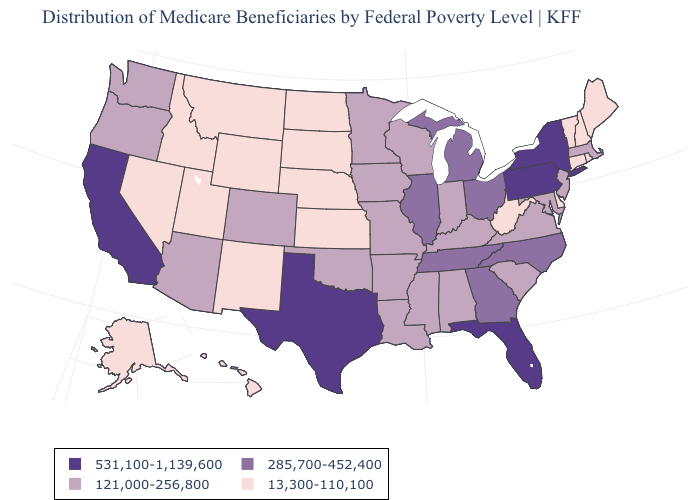Does California have the highest value in the USA?
Answer briefly. Yes. Does Delaware have the lowest value in the South?
Be succinct. Yes. What is the highest value in states that border Indiana?
Concise answer only. 285,700-452,400. Name the states that have a value in the range 285,700-452,400?
Be succinct. Georgia, Illinois, Michigan, North Carolina, Ohio, Tennessee. Does West Virginia have a higher value than South Carolina?
Write a very short answer. No. Name the states that have a value in the range 121,000-256,800?
Keep it brief. Alabama, Arizona, Arkansas, Colorado, Indiana, Iowa, Kentucky, Louisiana, Maryland, Massachusetts, Minnesota, Mississippi, Missouri, New Jersey, Oklahoma, Oregon, South Carolina, Virginia, Washington, Wisconsin. Among the states that border Ohio , does West Virginia have the lowest value?
Quick response, please. Yes. Among the states that border Idaho , does Oregon have the highest value?
Give a very brief answer. Yes. Which states hav the highest value in the South?
Be succinct. Florida, Texas. What is the value of Minnesota?
Concise answer only. 121,000-256,800. What is the value of Hawaii?
Keep it brief. 13,300-110,100. What is the highest value in the MidWest ?
Answer briefly. 285,700-452,400. Does Pennsylvania have the lowest value in the Northeast?
Concise answer only. No. What is the value of Missouri?
Give a very brief answer. 121,000-256,800. What is the value of Nevada?
Give a very brief answer. 13,300-110,100. 